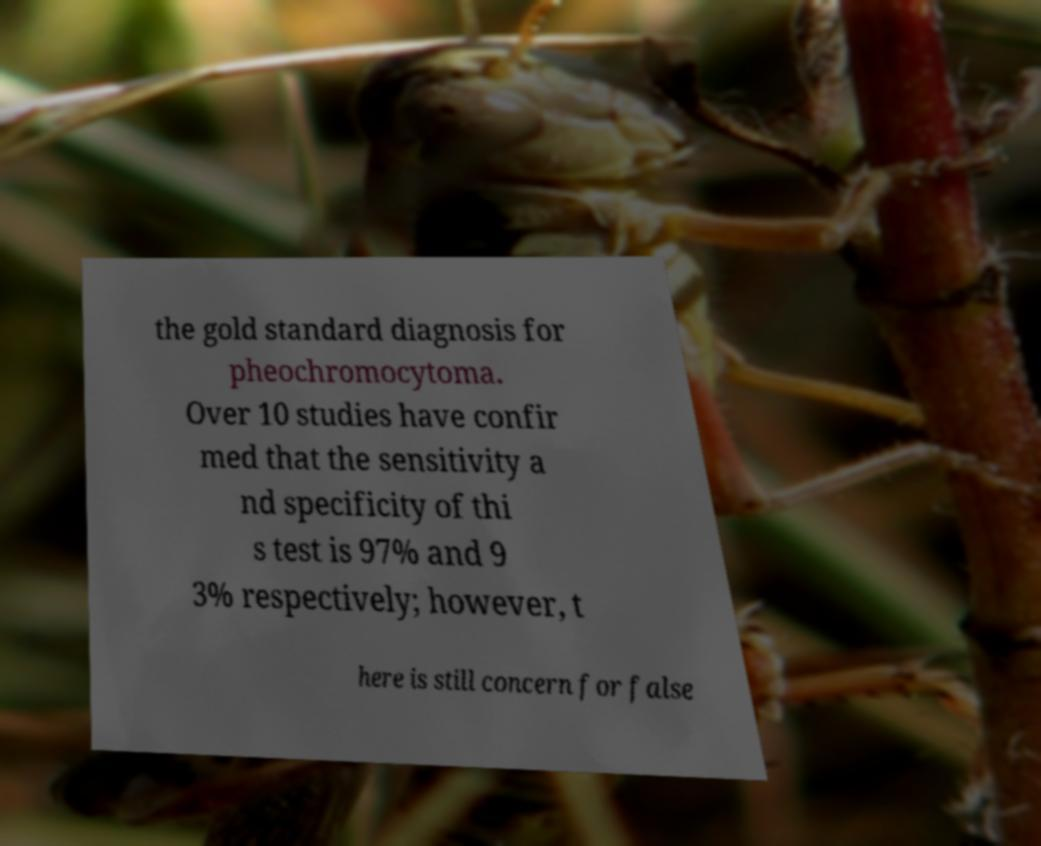Can you read and provide the text displayed in the image?This photo seems to have some interesting text. Can you extract and type it out for me? the gold standard diagnosis for pheochromocytoma. Over 10 studies have confir med that the sensitivity a nd specificity of thi s test is 97% and 9 3% respectively; however, t here is still concern for false 